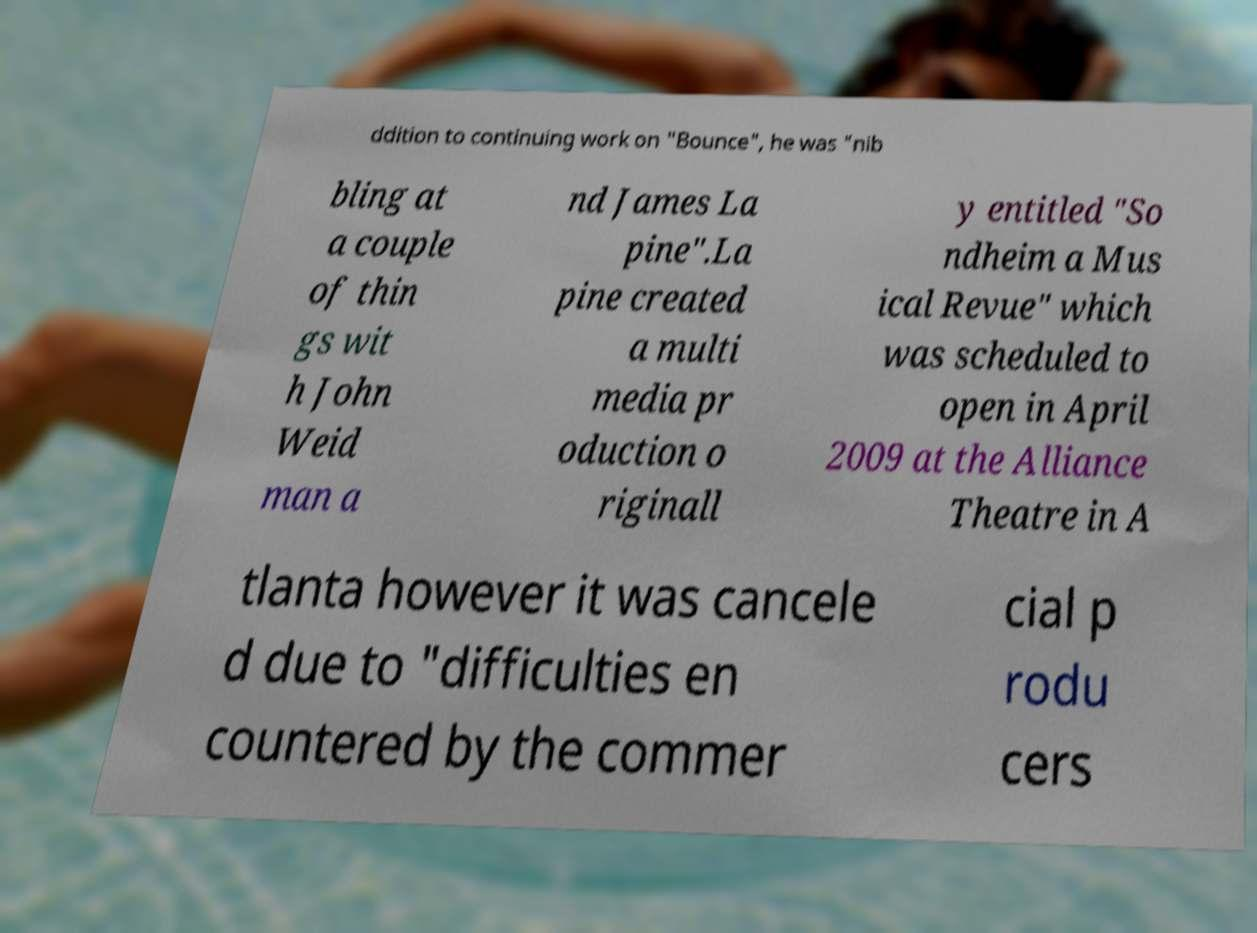For documentation purposes, I need the text within this image transcribed. Could you provide that? ddition to continuing work on "Bounce", he was "nib bling at a couple of thin gs wit h John Weid man a nd James La pine".La pine created a multi media pr oduction o riginall y entitled "So ndheim a Mus ical Revue" which was scheduled to open in April 2009 at the Alliance Theatre in A tlanta however it was cancele d due to "difficulties en countered by the commer cial p rodu cers 